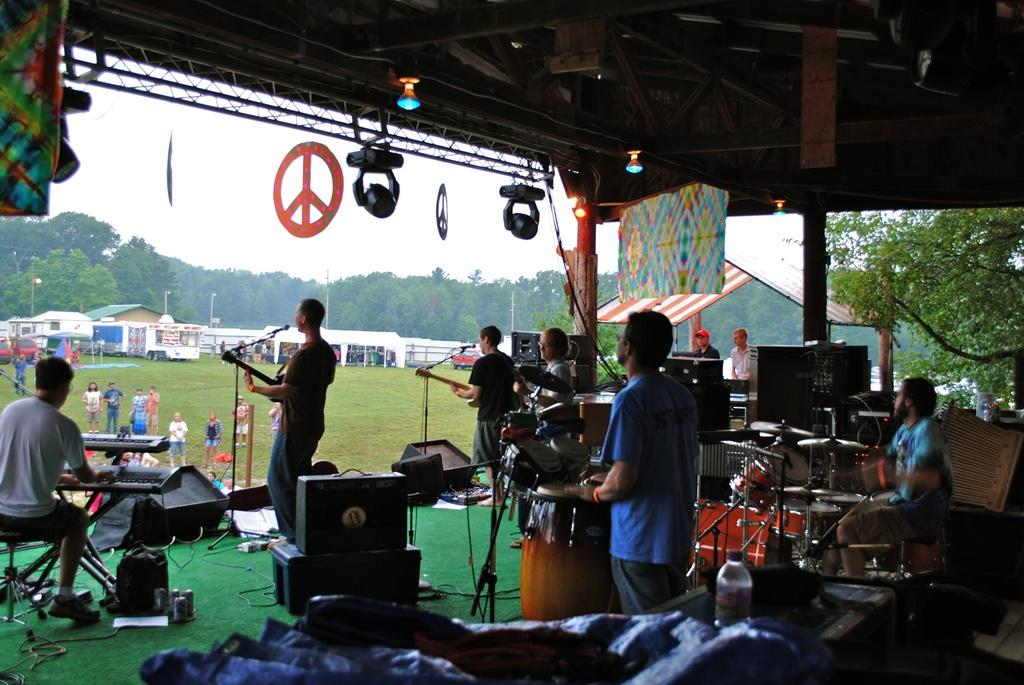What is happening on the stage in the image? There is a group of people on stage, and they are performing. What are the people on stage doing while performing? They are playing musical instruments. What can be seen in front of the stage? Buildings, vehicles, children, people, and trees are visible in front of the stage. What type of attraction is the group of people on stage leading in the image? There is no attraction or leading mentioned in the image. The people on stage are simply performing with musical instruments. What type of trade is being conducted between the children and the vehicles in front of the stage? There is no trade or interaction between the children and the vehicles in the image. They are simply present in front of the stage. 